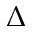Convert formula to latex. <formula><loc_0><loc_0><loc_500><loc_500>\Delta</formula> 